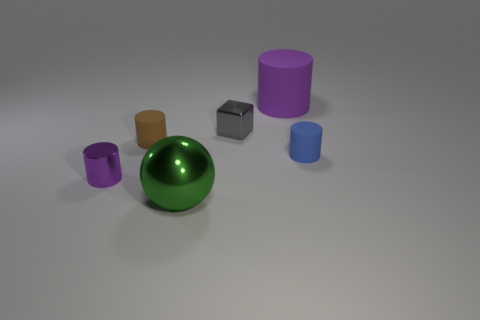Subtract all cyan spheres. How many purple cylinders are left? 2 Subtract all small purple cylinders. How many cylinders are left? 3 Add 1 large gray shiny spheres. How many objects exist? 7 Subtract all brown cylinders. How many cylinders are left? 3 Subtract 1 cylinders. How many cylinders are left? 3 Subtract all balls. How many objects are left? 5 Subtract all tiny brown cylinders. Subtract all tiny red matte cylinders. How many objects are left? 5 Add 6 purple cylinders. How many purple cylinders are left? 8 Add 4 gray things. How many gray things exist? 5 Subtract 0 purple balls. How many objects are left? 6 